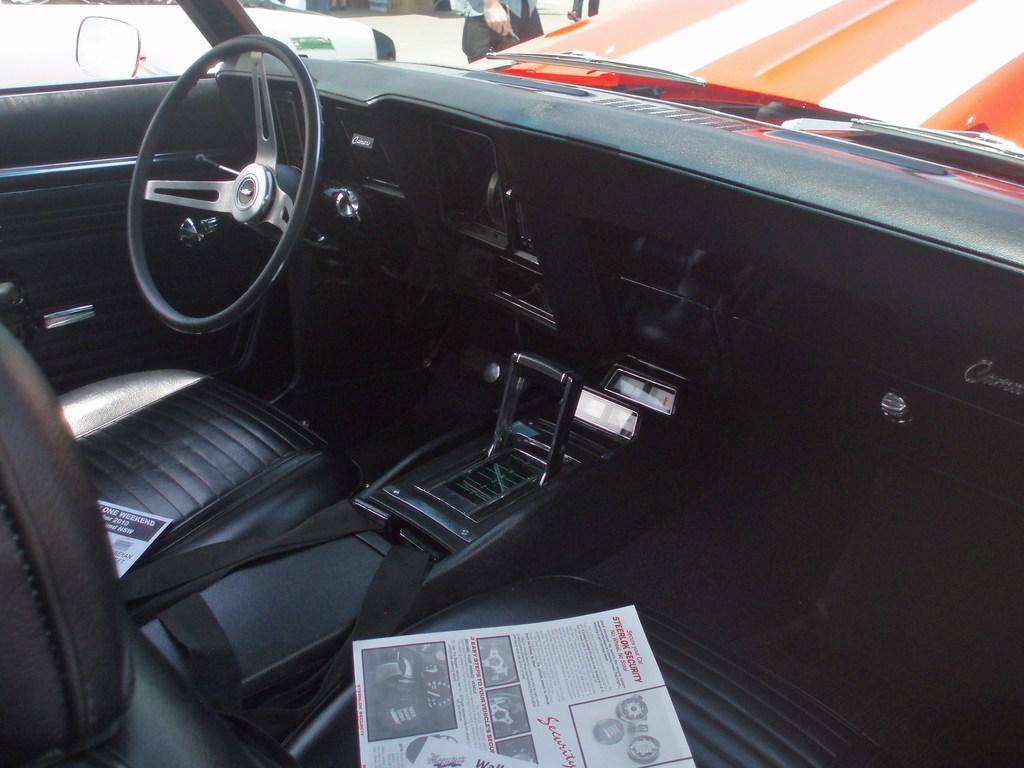What is the setting of the image? The image shows the inside view of a car. What can be seen on the seats in the car? There are two newspapers on the seats. Who or what can be seen through the car glass door? There are persons visible through the car glass door. What is the view outside the car? There is a road visible through the car glass door. What other objects can be seen through the car glass door? Other objects are visible through the car glass door. What type of mint can be seen growing on the side of the road in the image? There is no mint visible in the image; it only shows the inside view of a car with a view of the road and other objects through the car glass door. 